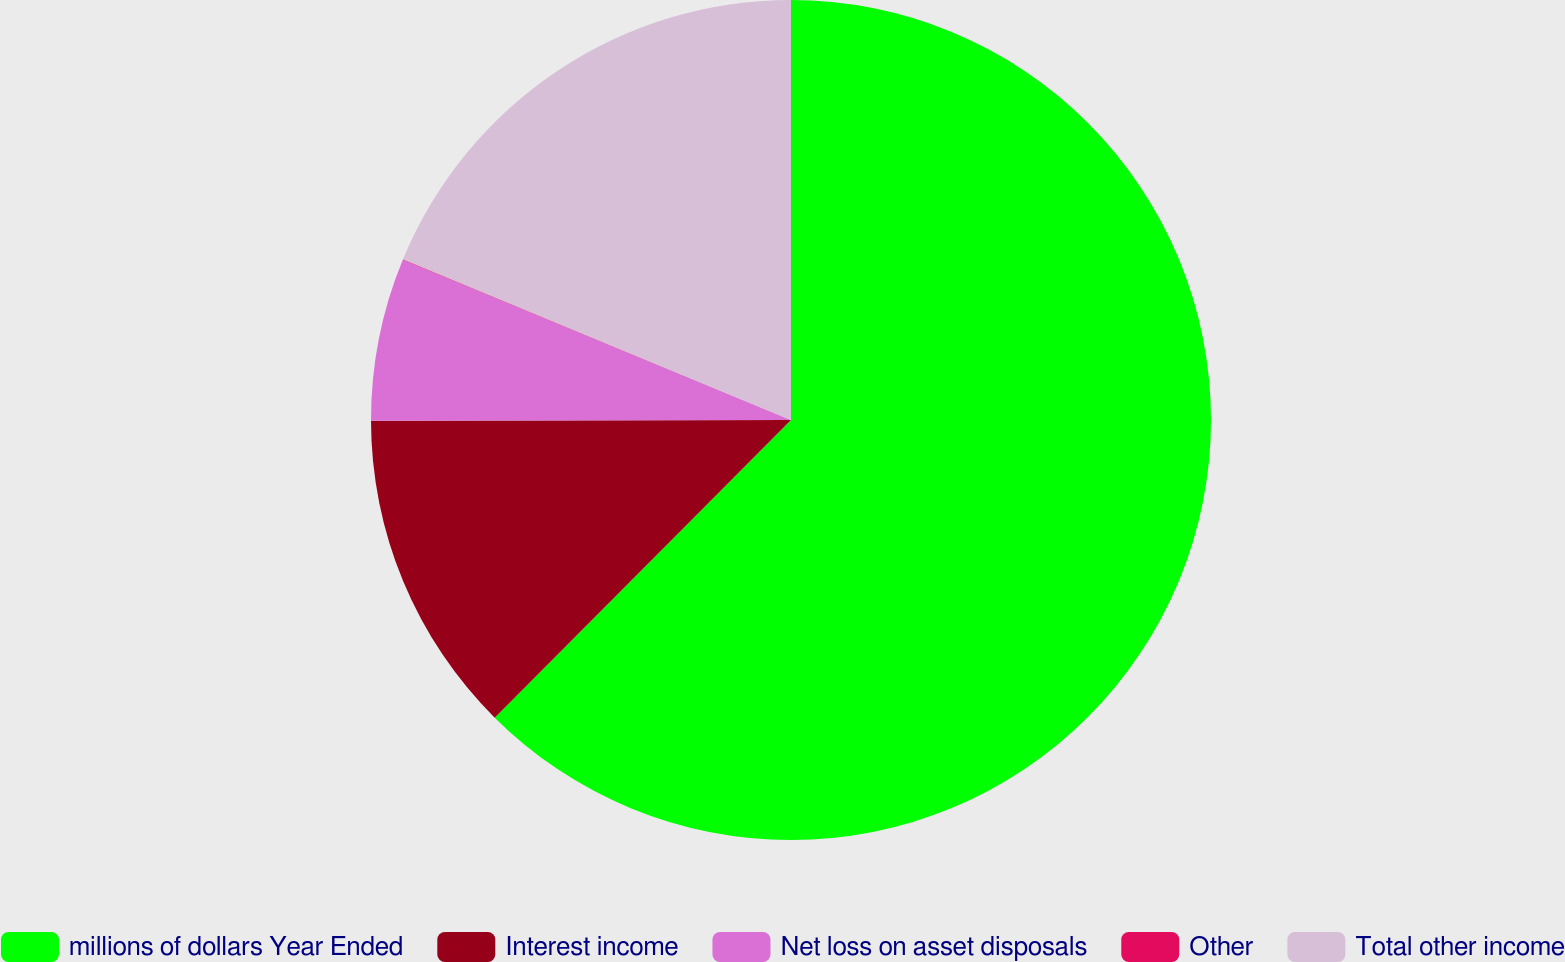<chart> <loc_0><loc_0><loc_500><loc_500><pie_chart><fcel>millions of dollars Year Ended<fcel>Interest income<fcel>Net loss on asset disposals<fcel>Other<fcel>Total other income<nl><fcel>62.47%<fcel>12.51%<fcel>6.26%<fcel>0.02%<fcel>18.75%<nl></chart> 